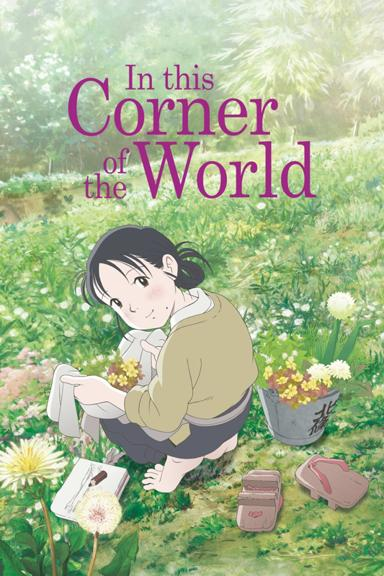What might the girl be doing in the image? The girl appears to be engaged in picking flowers or possibly sketching the scenery. She has a peaceful expression, which suggests she is enjoying her interaction with nature, either collecting different flowers or capturing the beauty of her surroundings on paper. 